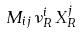<formula> <loc_0><loc_0><loc_500><loc_500>M _ { i j } \, \nu ^ { i } _ { R } \, X ^ { j } _ { R }</formula> 